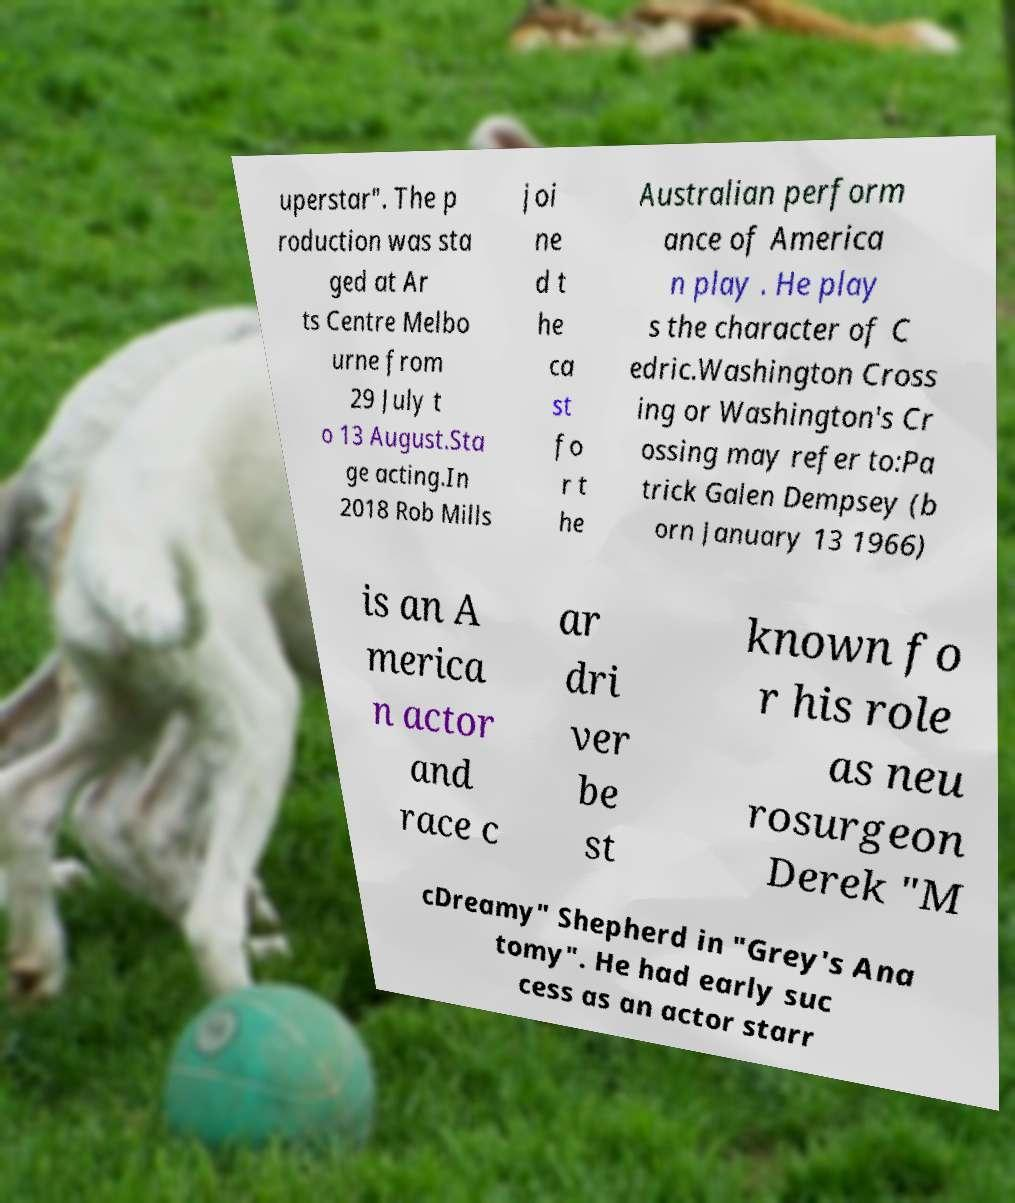Could you assist in decoding the text presented in this image and type it out clearly? uperstar". The p roduction was sta ged at Ar ts Centre Melbo urne from 29 July t o 13 August.Sta ge acting.In 2018 Rob Mills joi ne d t he ca st fo r t he Australian perform ance of America n play . He play s the character of C edric.Washington Cross ing or Washington's Cr ossing may refer to:Pa trick Galen Dempsey (b orn January 13 1966) is an A merica n actor and race c ar dri ver be st known fo r his role as neu rosurgeon Derek "M cDreamy" Shepherd in "Grey's Ana tomy". He had early suc cess as an actor starr 